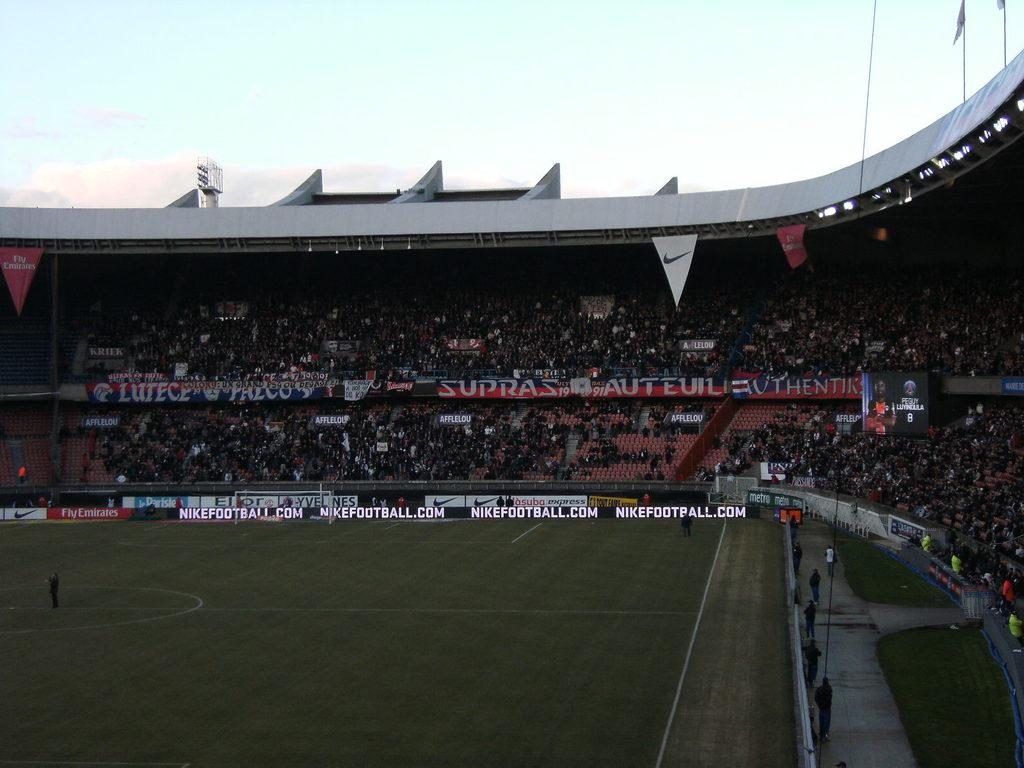Provide a one-sentence caption for the provided image. A stadium has nikefootball.com displayed near the edge of the field. 